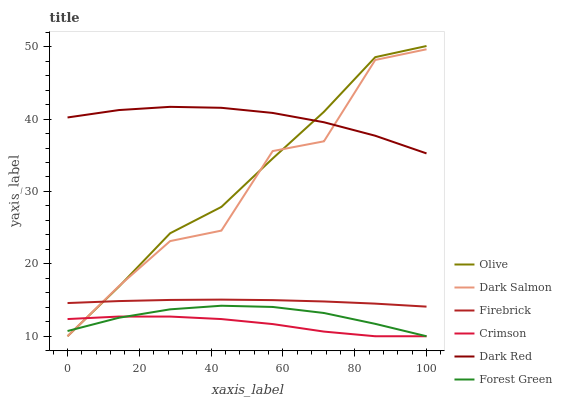Does Crimson have the minimum area under the curve?
Answer yes or no. Yes. Does Dark Red have the maximum area under the curve?
Answer yes or no. Yes. Does Firebrick have the minimum area under the curve?
Answer yes or no. No. Does Firebrick have the maximum area under the curve?
Answer yes or no. No. Is Firebrick the smoothest?
Answer yes or no. Yes. Is Dark Salmon the roughest?
Answer yes or no. Yes. Is Dark Salmon the smoothest?
Answer yes or no. No. Is Firebrick the roughest?
Answer yes or no. No. Does Dark Salmon have the lowest value?
Answer yes or no. Yes. Does Firebrick have the lowest value?
Answer yes or no. No. Does Olive have the highest value?
Answer yes or no. Yes. Does Firebrick have the highest value?
Answer yes or no. No. Is Forest Green less than Dark Red?
Answer yes or no. Yes. Is Firebrick greater than Forest Green?
Answer yes or no. Yes. Does Crimson intersect Olive?
Answer yes or no. Yes. Is Crimson less than Olive?
Answer yes or no. No. Is Crimson greater than Olive?
Answer yes or no. No. Does Forest Green intersect Dark Red?
Answer yes or no. No. 